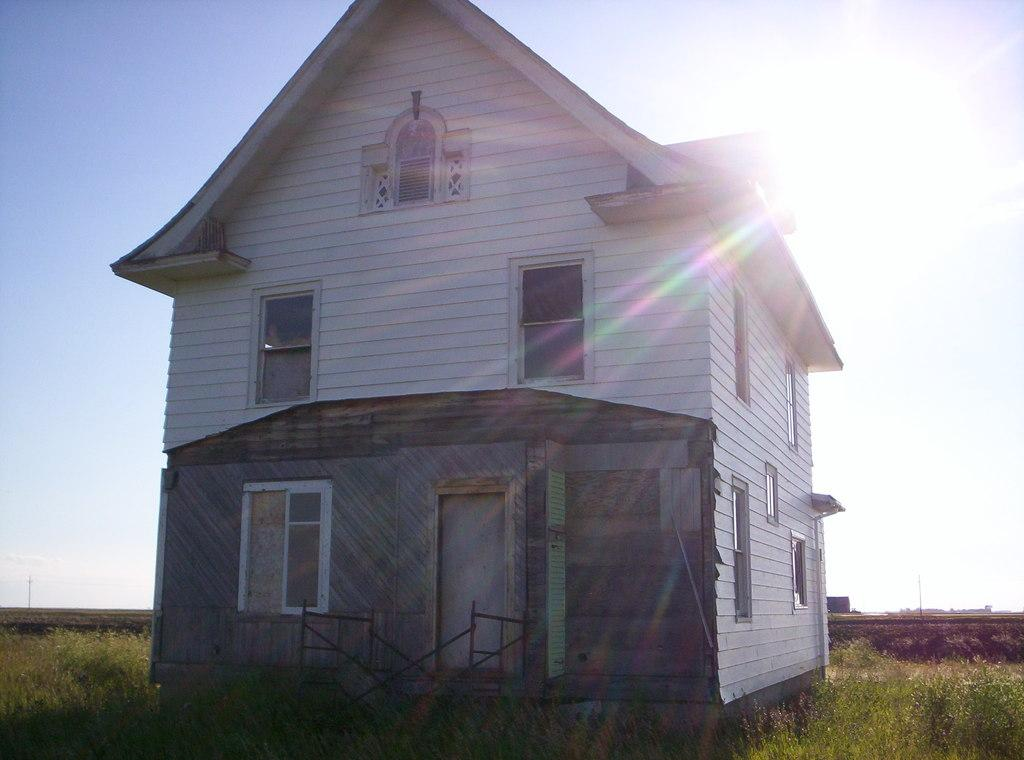What is the main structure in the center of the image? There is a house in the center of the image. What can be seen in the background of the image? There is sunlight visible in the background. What type of vegetation covers the ground in the image? The ground is covered with grass. What objects are present at the bottom of the image? There are poles present at the bottom of the image. What type of support can be seen in the image for the oranges? There are no oranges or any support for them present in the image. 